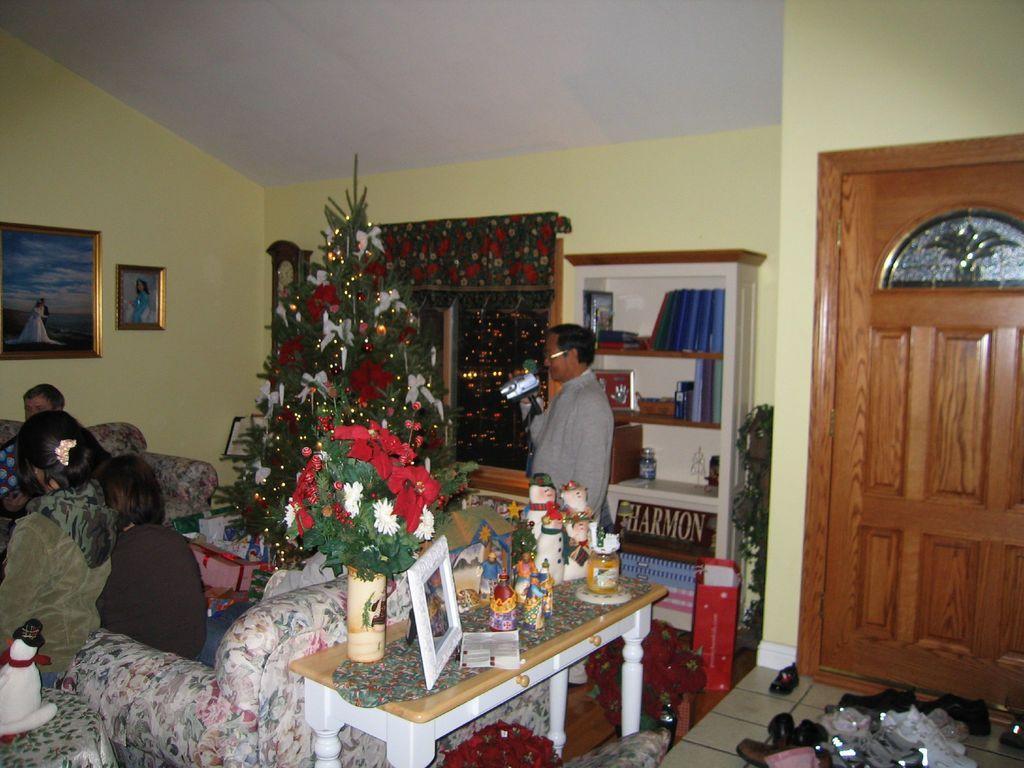Can you describe this image briefly? in a room there is a table on which there are flower pot, photo frame, toys and other objects. Behind that people are seated on the sofa. At the back there is a Christmas tree. A person is standing in the center holding a camera. Behind him there is a shelf in which there are books. To its left there is a window. At the back there is a yellow wall on which there are 2 photo frames at the left. At the right there is a door, in front of it there are shoes. 